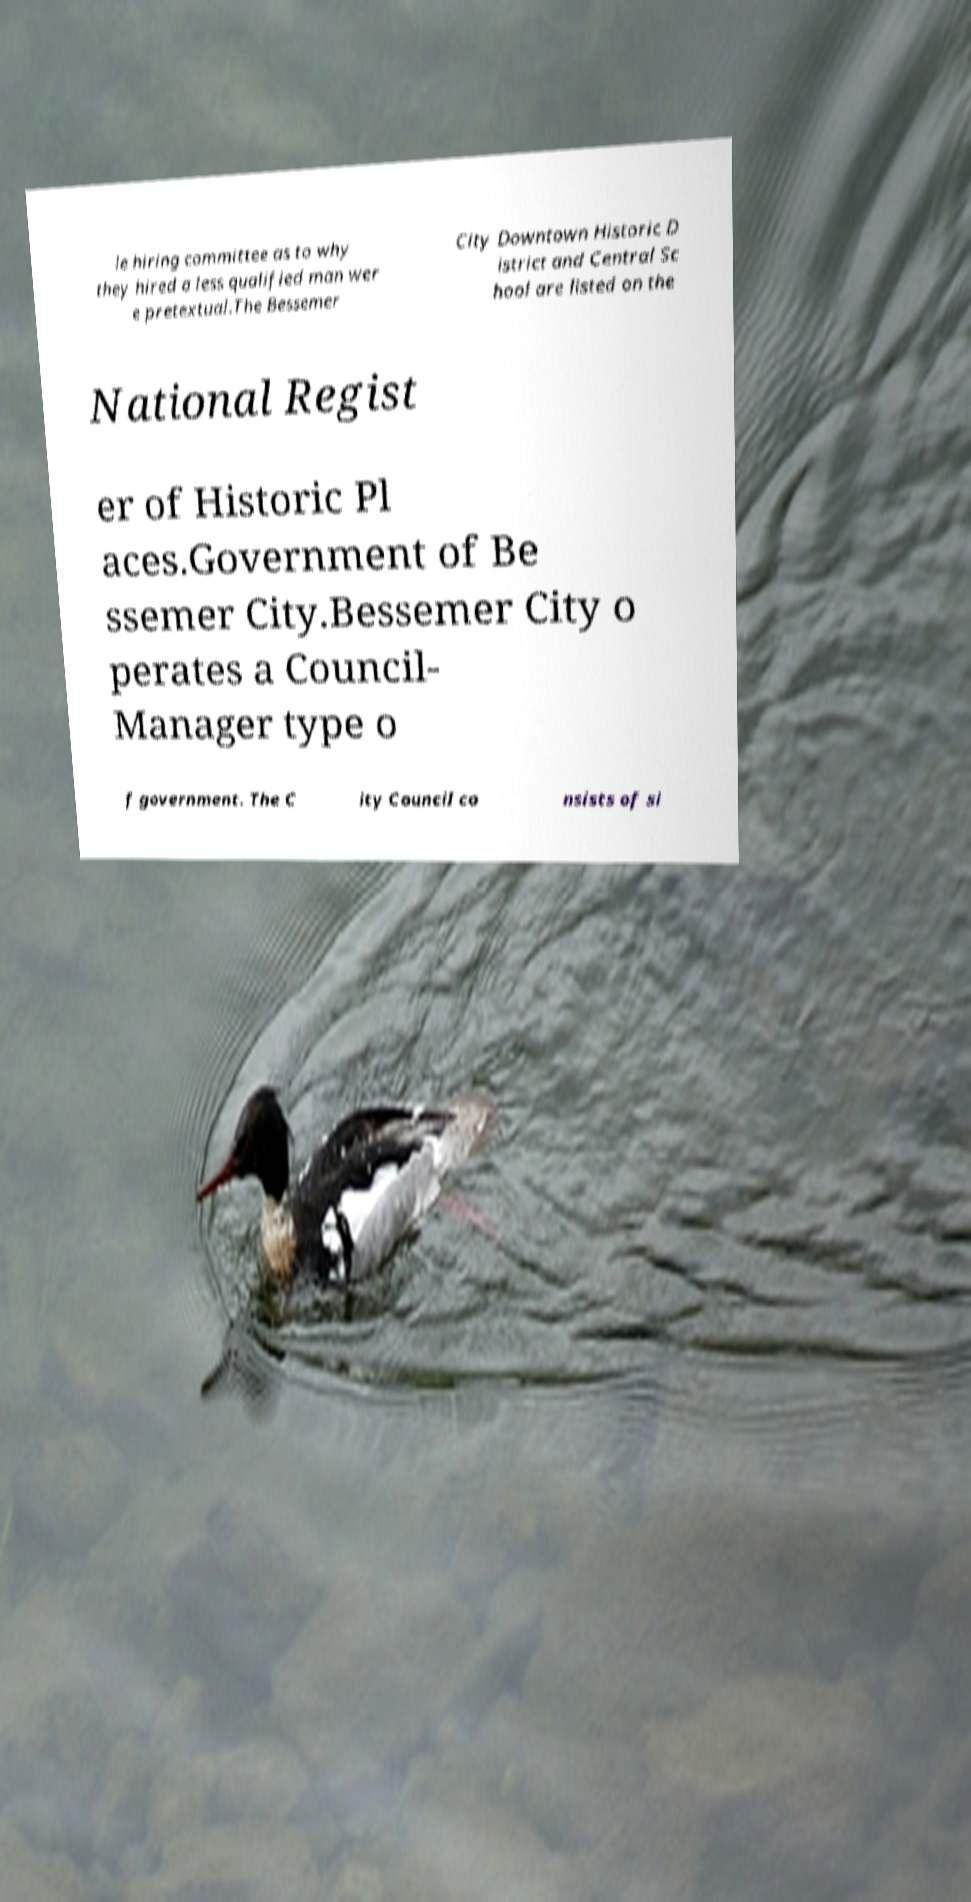Could you assist in decoding the text presented in this image and type it out clearly? le hiring committee as to why they hired a less qualified man wer e pretextual.The Bessemer City Downtown Historic D istrict and Central Sc hool are listed on the National Regist er of Historic Pl aces.Government of Be ssemer City.Bessemer City o perates a Council- Manager type o f government. The C ity Council co nsists of si 